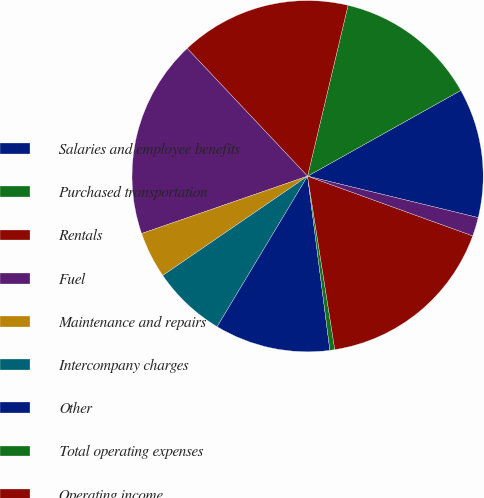Convert chart. <chart><loc_0><loc_0><loc_500><loc_500><pie_chart><fcel>Salaries and employee benefits<fcel>Purchased transportation<fcel>Rentals<fcel>Fuel<fcel>Maintenance and repairs<fcel>Intercompany charges<fcel>Other<fcel>Total operating expenses<fcel>Operating income<fcel>Priority<nl><fcel>11.91%<fcel>13.18%<fcel>15.73%<fcel>18.27%<fcel>4.27%<fcel>6.82%<fcel>10.64%<fcel>0.45%<fcel>17.0%<fcel>1.73%<nl></chart> 